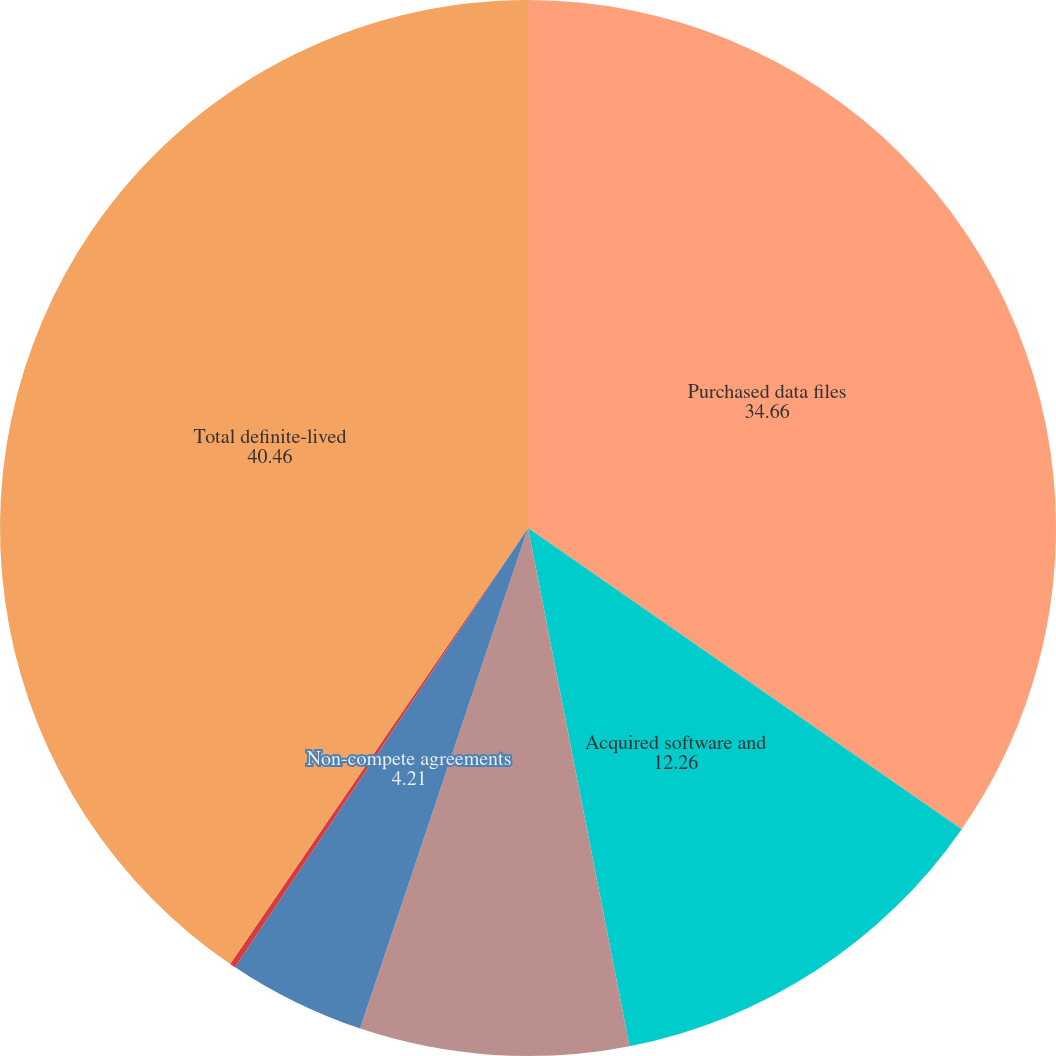Convert chart. <chart><loc_0><loc_0><loc_500><loc_500><pie_chart><fcel>Purchased data files<fcel>Acquired software and<fcel>Customer relationships<fcel>Non-compete agreements<fcel>Trade names and other<fcel>Total definite-lived<nl><fcel>34.66%<fcel>12.26%<fcel>8.23%<fcel>4.21%<fcel>0.18%<fcel>40.46%<nl></chart> 